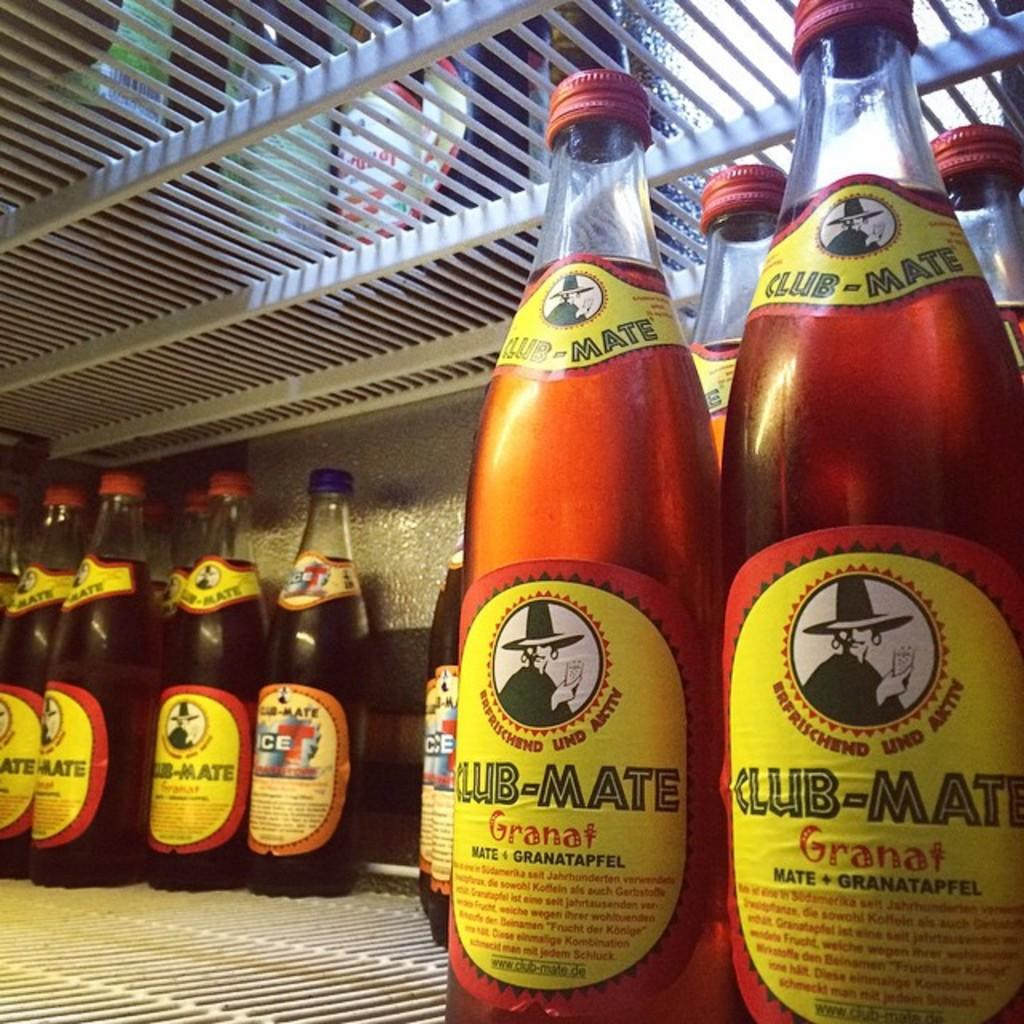<image>
Give a short and clear explanation of the subsequent image. the word granat is on the bottle of liquid 